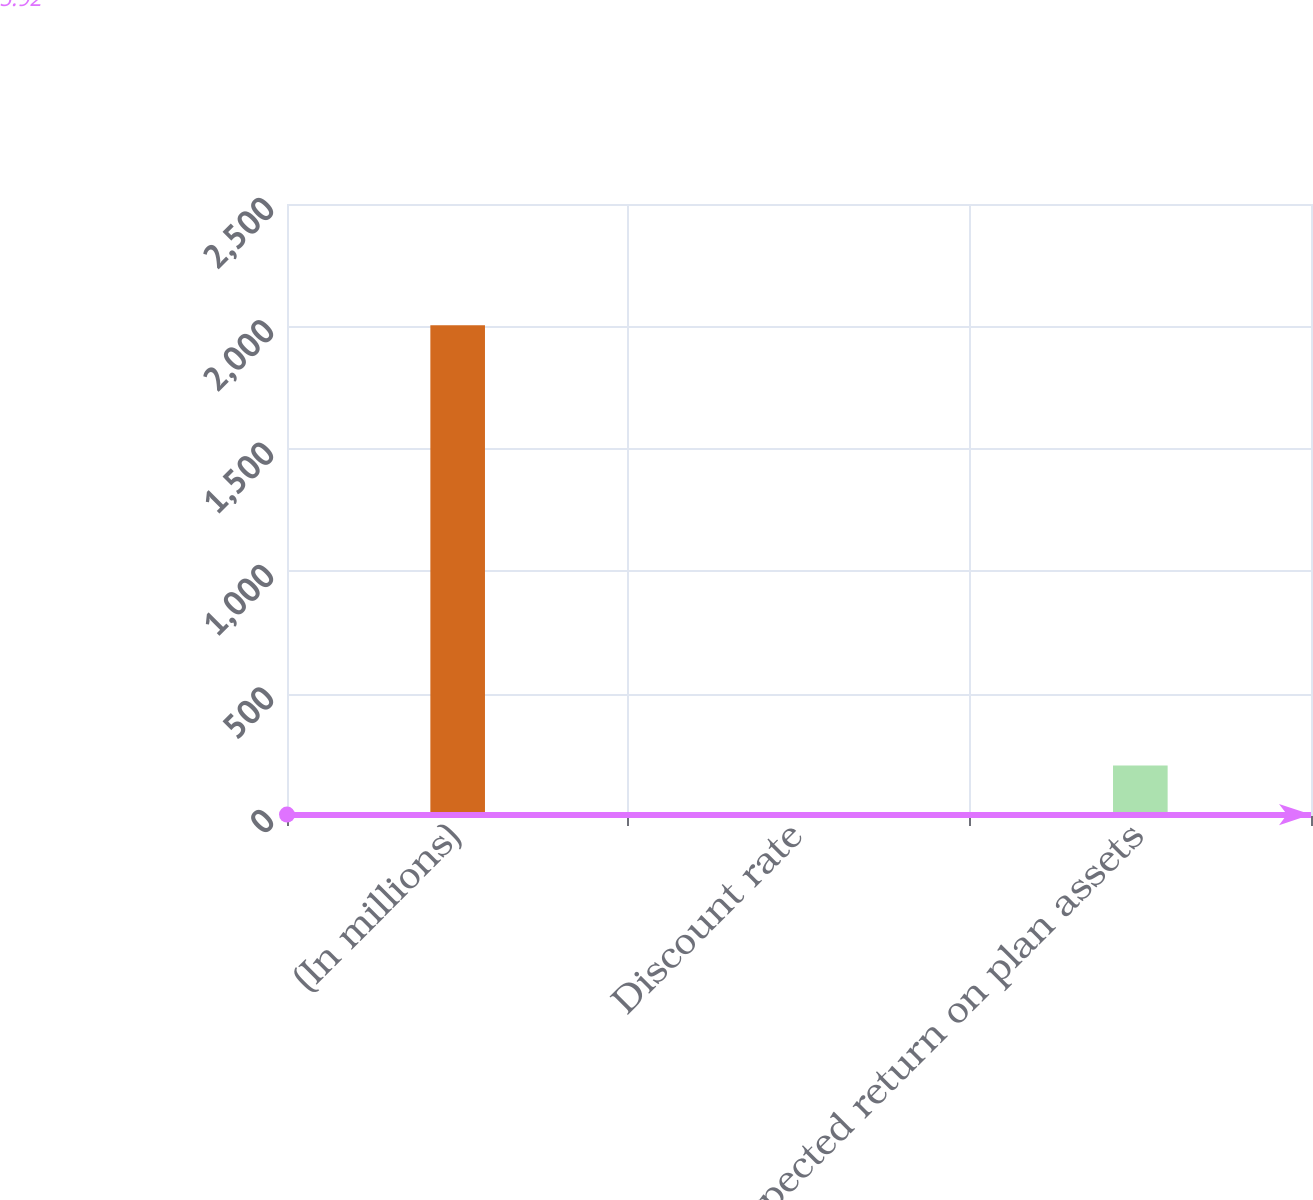<chart> <loc_0><loc_0><loc_500><loc_500><bar_chart><fcel>(In millions)<fcel>Discount rate<fcel>Expected return on plan assets<nl><fcel>2005<fcel>5.92<fcel>205.83<nl></chart> 